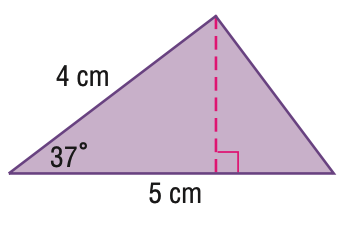Question: Find the area of the triangle. Round to the nearest hundredth.
Choices:
A. 6.02
B. 7.54
C. 7.99
D. 9.42
Answer with the letter. Answer: A 